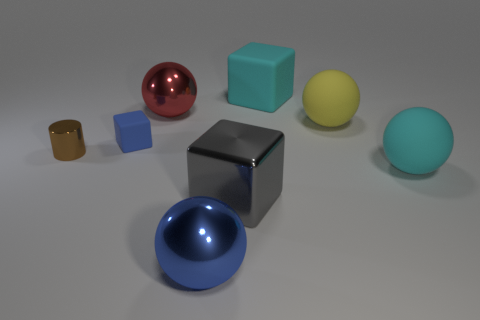Are there fewer balls that are in front of the tiny brown metallic object than tiny cubes?
Offer a terse response. No. What is the size of the shiny ball that is in front of the shiny object on the right side of the big blue thing?
Provide a short and direct response. Large. There is a small rubber thing; is it the same color as the large shiny ball in front of the red sphere?
Provide a succinct answer. Yes. There is a yellow object that is the same size as the gray object; what material is it?
Offer a very short reply. Rubber. Is the number of cyan things in front of the red object less than the number of things behind the tiny shiny cylinder?
Provide a succinct answer. Yes. What shape is the cyan object in front of the metallic ball behind the tiny brown metallic thing?
Make the answer very short. Sphere. Are any large blue metal spheres visible?
Provide a succinct answer. Yes. There is a big cube that is behind the gray shiny thing; what is its color?
Your response must be concise. Cyan. There is a thing that is the same color as the small rubber cube; what is its material?
Give a very brief answer. Metal. Are there any cyan rubber blocks behind the brown thing?
Provide a succinct answer. Yes. 